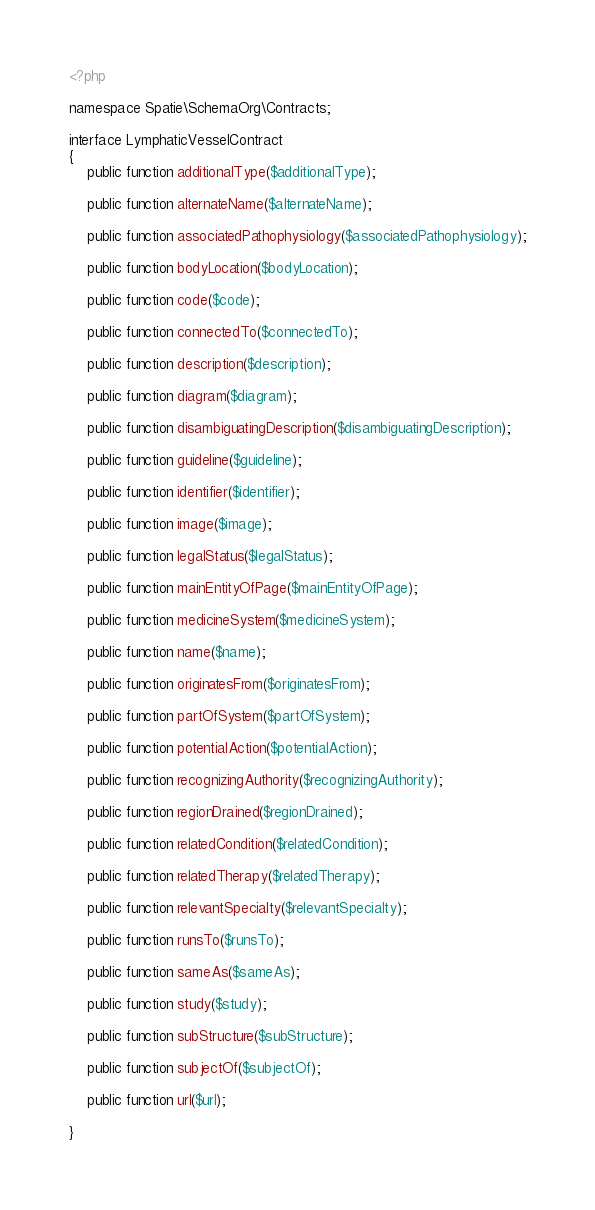<code> <loc_0><loc_0><loc_500><loc_500><_PHP_><?php

namespace Spatie\SchemaOrg\Contracts;

interface LymphaticVesselContract
{
    public function additionalType($additionalType);

    public function alternateName($alternateName);

    public function associatedPathophysiology($associatedPathophysiology);

    public function bodyLocation($bodyLocation);

    public function code($code);

    public function connectedTo($connectedTo);

    public function description($description);

    public function diagram($diagram);

    public function disambiguatingDescription($disambiguatingDescription);

    public function guideline($guideline);

    public function identifier($identifier);

    public function image($image);

    public function legalStatus($legalStatus);

    public function mainEntityOfPage($mainEntityOfPage);

    public function medicineSystem($medicineSystem);

    public function name($name);

    public function originatesFrom($originatesFrom);

    public function partOfSystem($partOfSystem);

    public function potentialAction($potentialAction);

    public function recognizingAuthority($recognizingAuthority);

    public function regionDrained($regionDrained);

    public function relatedCondition($relatedCondition);

    public function relatedTherapy($relatedTherapy);

    public function relevantSpecialty($relevantSpecialty);

    public function runsTo($runsTo);

    public function sameAs($sameAs);

    public function study($study);

    public function subStructure($subStructure);

    public function subjectOf($subjectOf);

    public function url($url);

}
</code> 